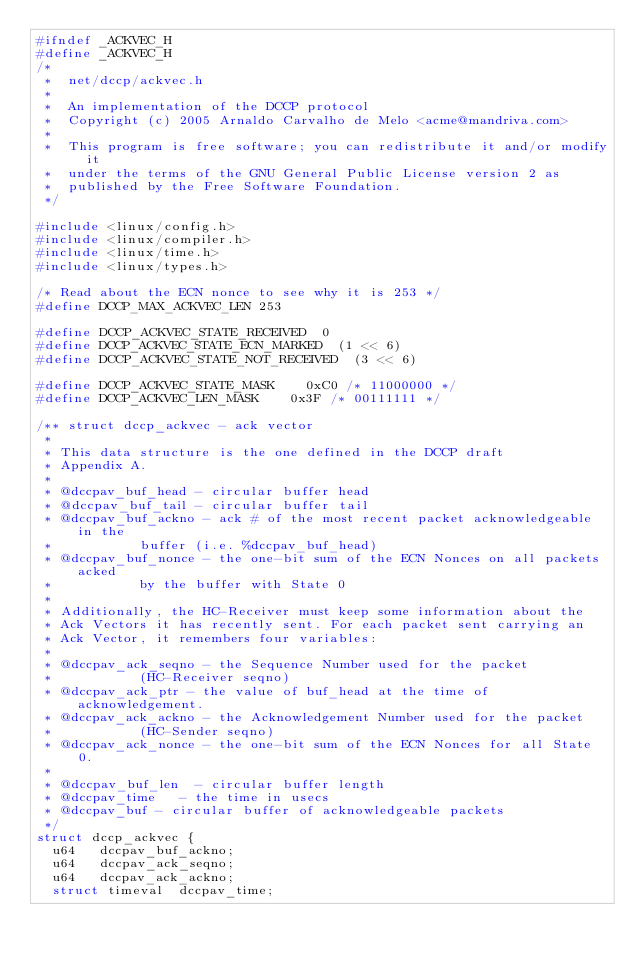<code> <loc_0><loc_0><loc_500><loc_500><_C_>#ifndef _ACKVEC_H
#define _ACKVEC_H
/*
 *  net/dccp/ackvec.h
 *
 *  An implementation of the DCCP protocol
 *  Copyright (c) 2005 Arnaldo Carvalho de Melo <acme@mandriva.com>
 *
 *	This program is free software; you can redistribute it and/or modify it
 *	under the terms of the GNU General Public License version 2 as
 *	published by the Free Software Foundation.
 */

#include <linux/config.h>
#include <linux/compiler.h>
#include <linux/time.h>
#include <linux/types.h>

/* Read about the ECN nonce to see why it is 253 */
#define DCCP_MAX_ACKVEC_LEN 253

#define DCCP_ACKVEC_STATE_RECEIVED	0
#define DCCP_ACKVEC_STATE_ECN_MARKED	(1 << 6)
#define DCCP_ACKVEC_STATE_NOT_RECEIVED	(3 << 6)

#define DCCP_ACKVEC_STATE_MASK		0xC0 /* 11000000 */
#define DCCP_ACKVEC_LEN_MASK		0x3F /* 00111111 */

/** struct dccp_ackvec - ack vector
 *
 * This data structure is the one defined in the DCCP draft
 * Appendix A.
 *
 * @dccpav_buf_head - circular buffer head
 * @dccpav_buf_tail - circular buffer tail
 * @dccpav_buf_ackno - ack # of the most recent packet acknowledgeable in the
 * 		       buffer (i.e. %dccpav_buf_head)
 * @dccpav_buf_nonce - the one-bit sum of the ECN Nonces on all packets acked
 * 		       by the buffer with State 0
 *
 * Additionally, the HC-Receiver must keep some information about the
 * Ack Vectors it has recently sent. For each packet sent carrying an
 * Ack Vector, it remembers four variables:
 *
 * @dccpav_ack_seqno - the Sequence Number used for the packet
 * 		       (HC-Receiver seqno)
 * @dccpav_ack_ptr - the value of buf_head at the time of acknowledgement.
 * @dccpav_ack_ackno - the Acknowledgement Number used for the packet
 * 		       (HC-Sender seqno)
 * @dccpav_ack_nonce - the one-bit sum of the ECN Nonces for all State 0.
 *
 * @dccpav_buf_len	- circular buffer length
 * @dccpav_time		- the time in usecs
 * @dccpav_buf - circular buffer of acknowledgeable packets
 */
struct dccp_ackvec {
	u64		dccpav_buf_ackno;
	u64		dccpav_ack_seqno;
	u64		dccpav_ack_ackno;
	struct timeval	dccpav_time;</code> 